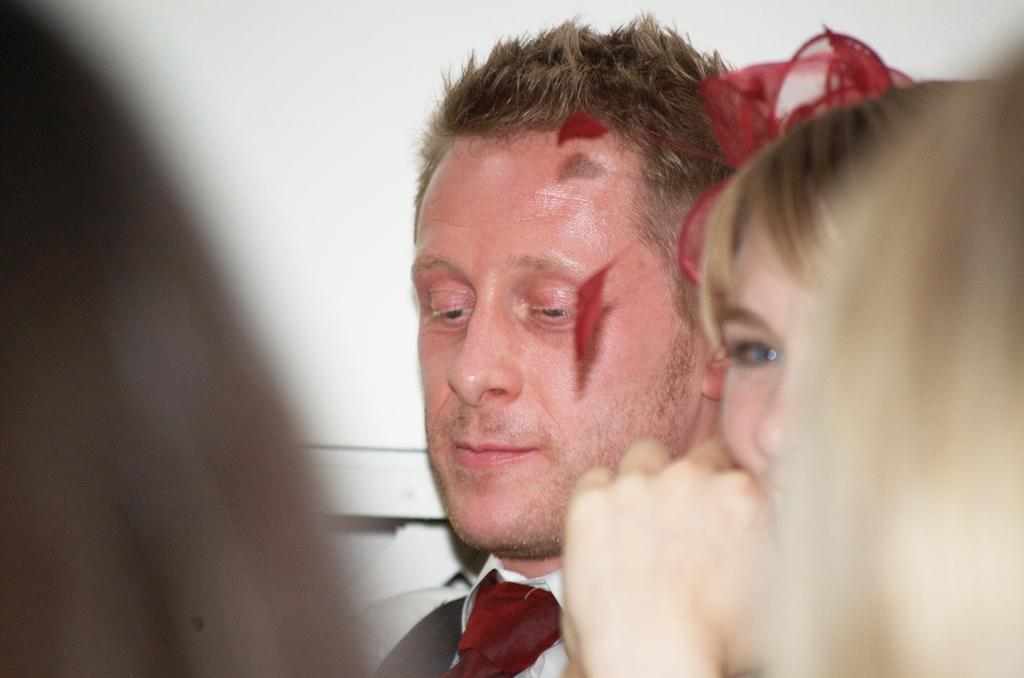How many people are in the image? There are two people in the image, a man and a woman. What can be seen in the background of the image? The background of the image is white. How many bottles are visible in the image? There are no bottles present in the image. What type of test is being conducted in the image? There is no test being conducted in the image. 